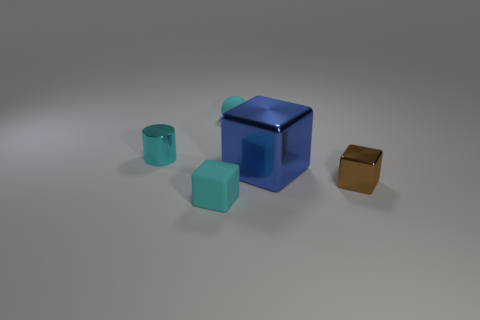Is the color of the tiny ball the same as the small shiny object that is left of the large metallic block? yes 